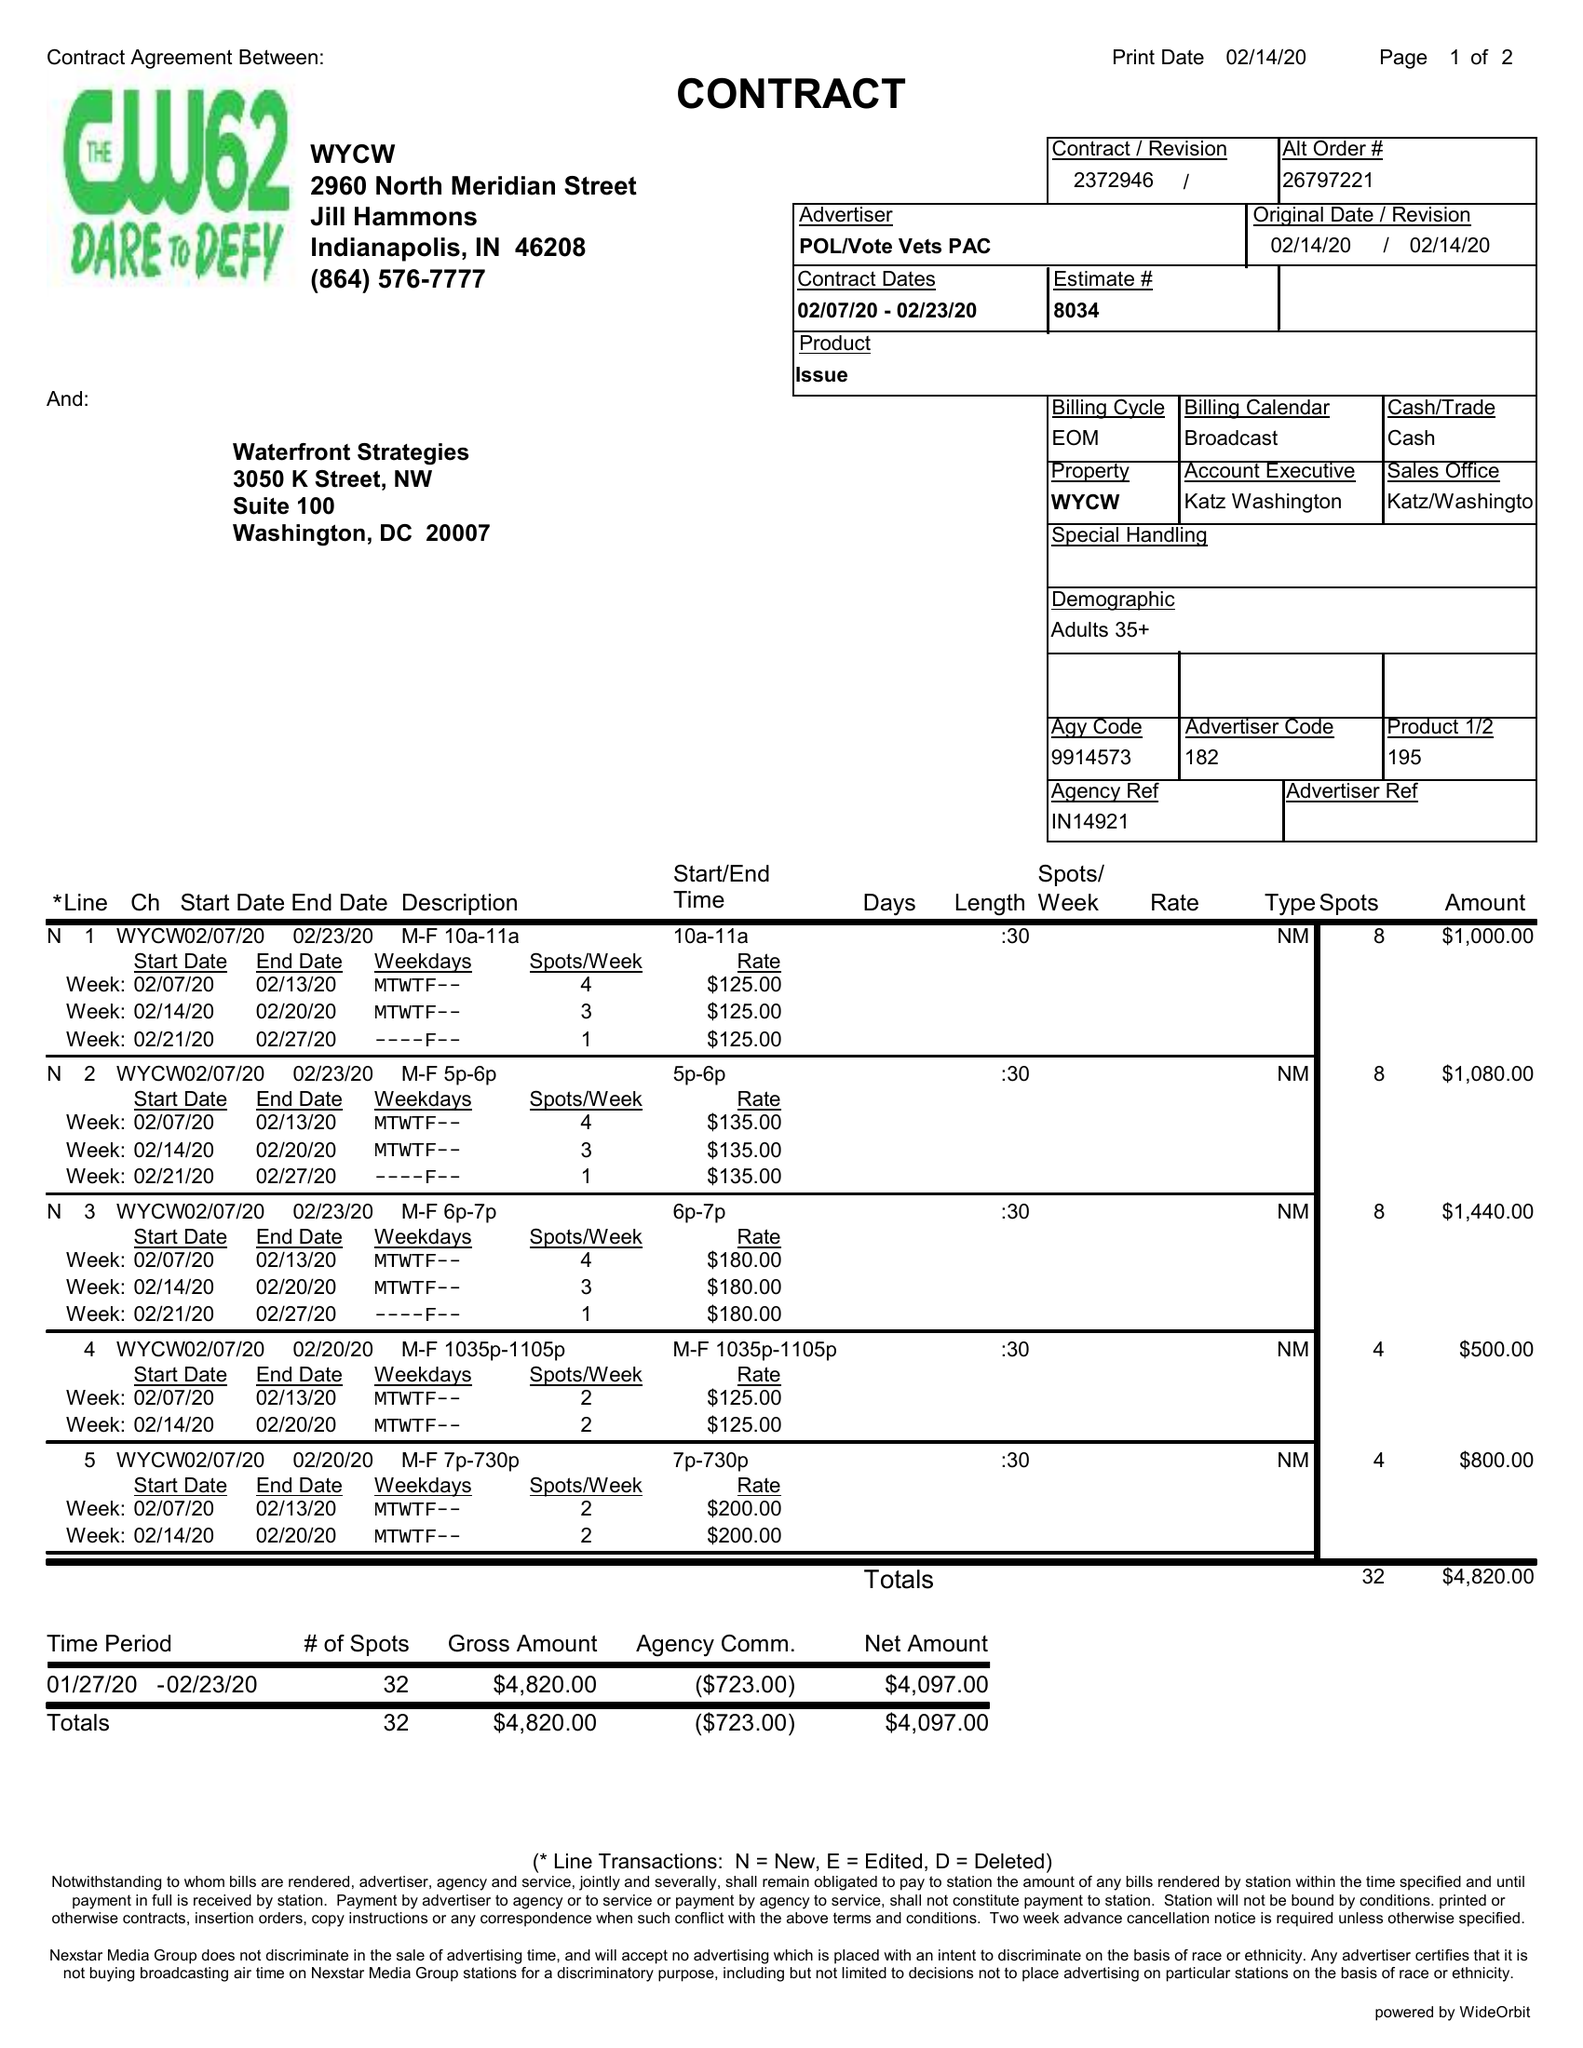What is the value for the gross_amount?
Answer the question using a single word or phrase. 4820.00 